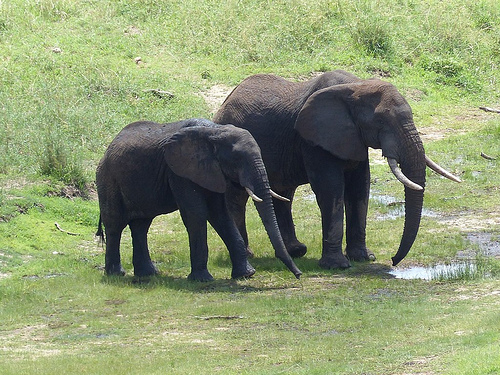Which kind of animal is the hill behind of? The hill is behind an elephant, prominently visible in the foreground. 